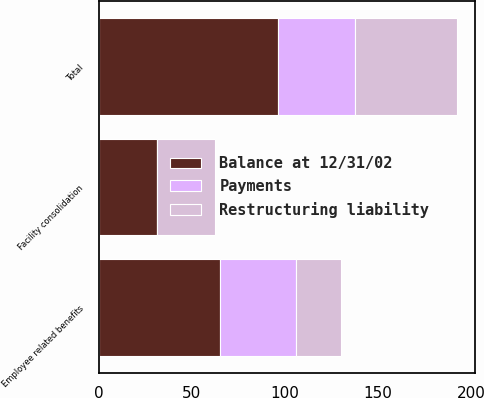<chart> <loc_0><loc_0><loc_500><loc_500><stacked_bar_chart><ecel><fcel>Employee related benefits<fcel>Facility consolidation<fcel>Total<nl><fcel>Balance at 12/31/02<fcel>65.1<fcel>31.2<fcel>96.3<nl><fcel>Payments<fcel>41<fcel>0.4<fcel>41.4<nl><fcel>Restructuring liability<fcel>24.1<fcel>30.8<fcel>54.9<nl></chart> 